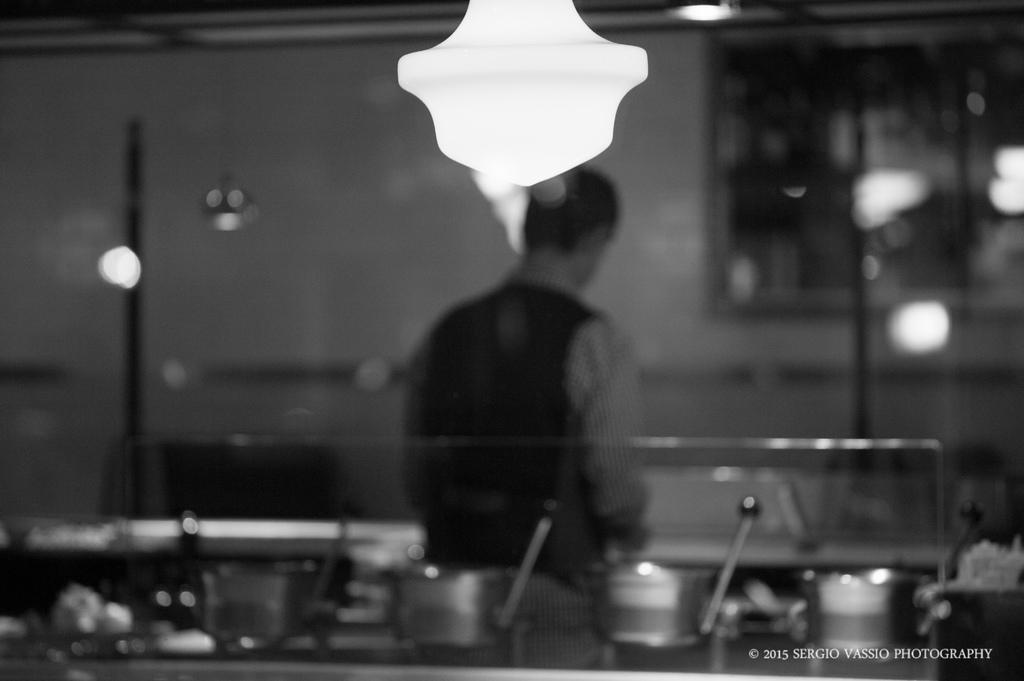Describe this image in one or two sentences. This is a black and white image. In the center of the image there is a person standing. At the top of the image there is a light. At the bottom of the image there are vessels on the table. 